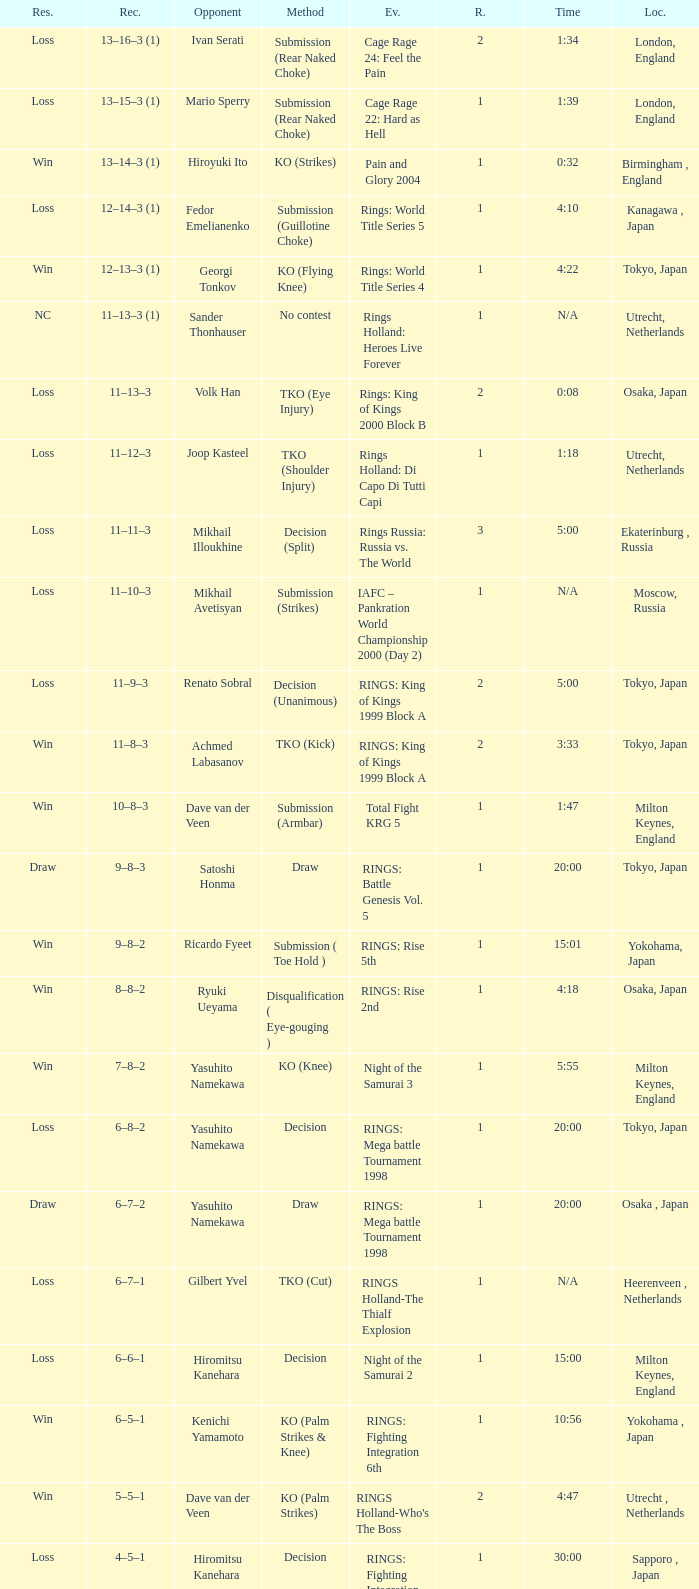What was the method for opponent of Ivan Serati? Submission (Rear Naked Choke). 